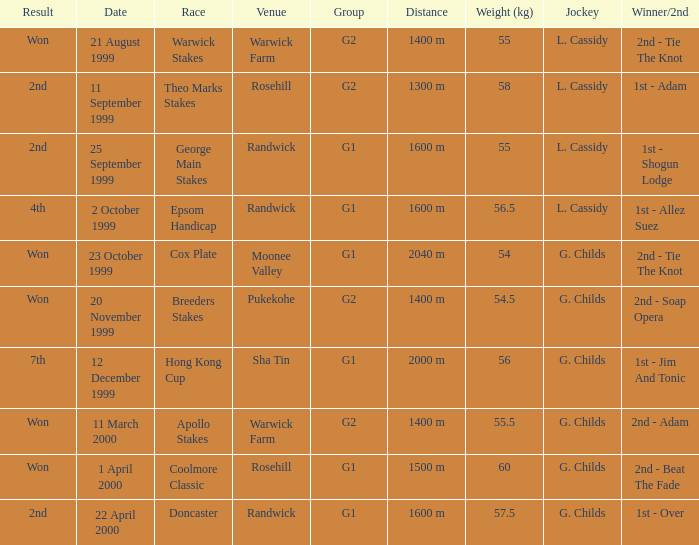List the weight for 56.5 kilograms. Epsom Handicap. 